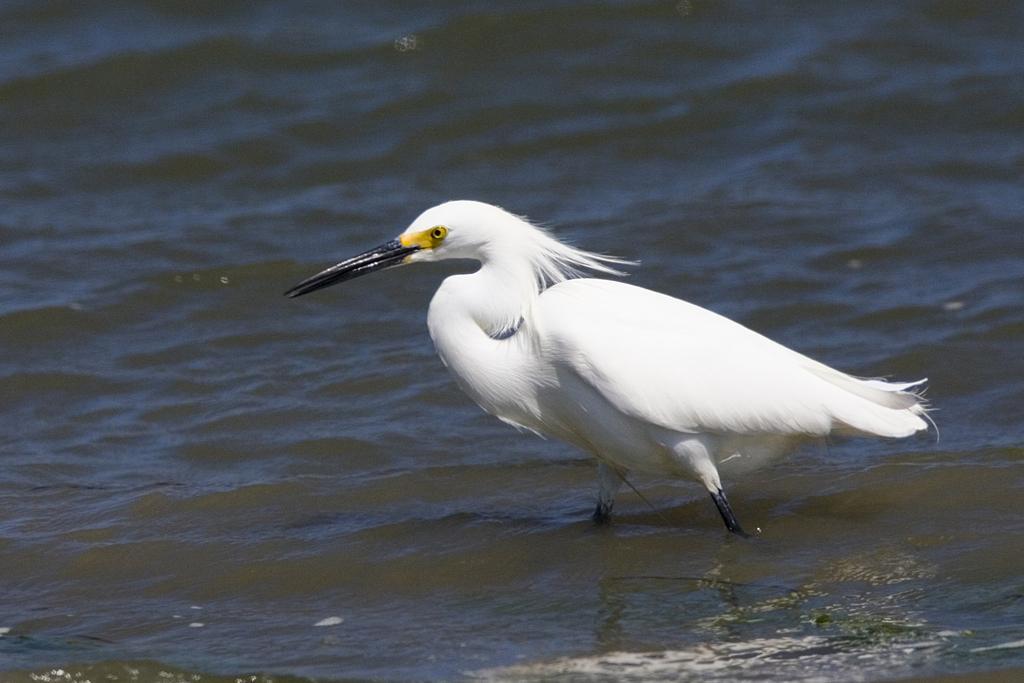In one or two sentences, can you explain what this image depicts? In this image we can see a bird which is in white color in the water. 